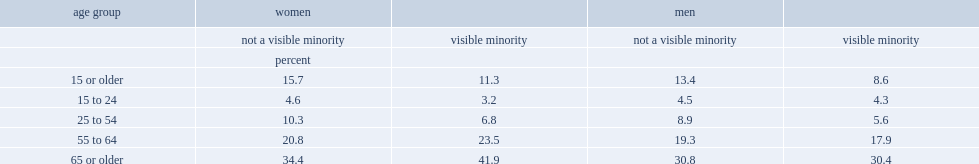Among minority women aged 15 or older, who were less likely to have disability, visible minority women or women who did not belong to a visible minority group? Visible minority. Among minority men aged 15 or older, who were less likely to have disability, visible minority men or men who did not belong to a visible minority group? Visible minority. Among minority women aged 15 to 24, who were less likely to have disability, visible minority women or women who did not belong to a visible minority group? Visible minority. Among minority women aged 25 to 54, who were less likely to have disability, visible minority women or women who did not belong to a visible minority group? Visible minority. Among minority women aged 65 or older, who were more likely to have disability, visible minority women or women who did not belong to a visible minority group? Visible minority. Among those aged 25 to 54, what was the percentag of visible minority women reported disabilities? 6.8. Among those aged 25 to 54, what was the percentag of visible minority women reported disabilities? 10.3. 